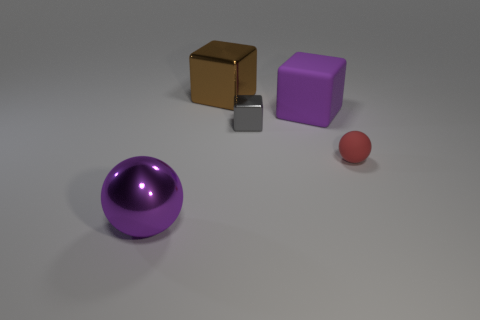Subtract all large blocks. How many blocks are left? 1 Subtract all purple spheres. How many spheres are left? 1 Add 2 cylinders. How many objects exist? 7 Subtract all blocks. How many objects are left? 2 Subtract all brown balls. How many purple blocks are left? 1 Subtract all purple balls. Subtract all brown blocks. How many balls are left? 1 Add 4 large brown shiny blocks. How many large brown shiny blocks are left? 5 Add 1 small blue cubes. How many small blue cubes exist? 1 Subtract 0 brown balls. How many objects are left? 5 Subtract all tiny purple rubber cubes. Subtract all tiny red objects. How many objects are left? 4 